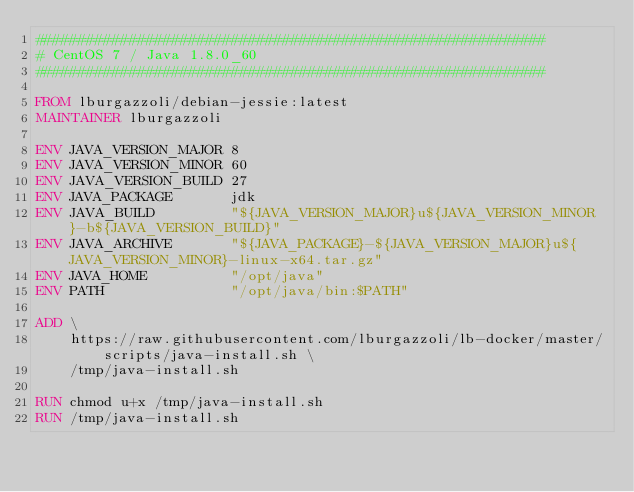Convert code to text. <code><loc_0><loc_0><loc_500><loc_500><_Dockerfile_>############################################################
# CentOS 7 / Java 1.8.0_60
############################################################

FROM lburgazzoli/debian-jessie:latest
MAINTAINER lburgazzoli

ENV JAVA_VERSION_MAJOR 8
ENV JAVA_VERSION_MINOR 60
ENV JAVA_VERSION_BUILD 27
ENV JAVA_PACKAGE       jdk
ENV JAVA_BUILD         "${JAVA_VERSION_MAJOR}u${JAVA_VERSION_MINOR}-b${JAVA_VERSION_BUILD}"
ENV JAVA_ARCHIVE       "${JAVA_PACKAGE}-${JAVA_VERSION_MAJOR}u${JAVA_VERSION_MINOR}-linux-x64.tar.gz"
ENV JAVA_HOME          "/opt/java"
ENV PATH               "/opt/java/bin:$PATH"

ADD \
    https://raw.githubusercontent.com/lburgazzoli/lb-docker/master/scripts/java-install.sh \
    /tmp/java-install.sh

RUN chmod u+x /tmp/java-install.sh
RUN /tmp/java-install.sh

</code> 